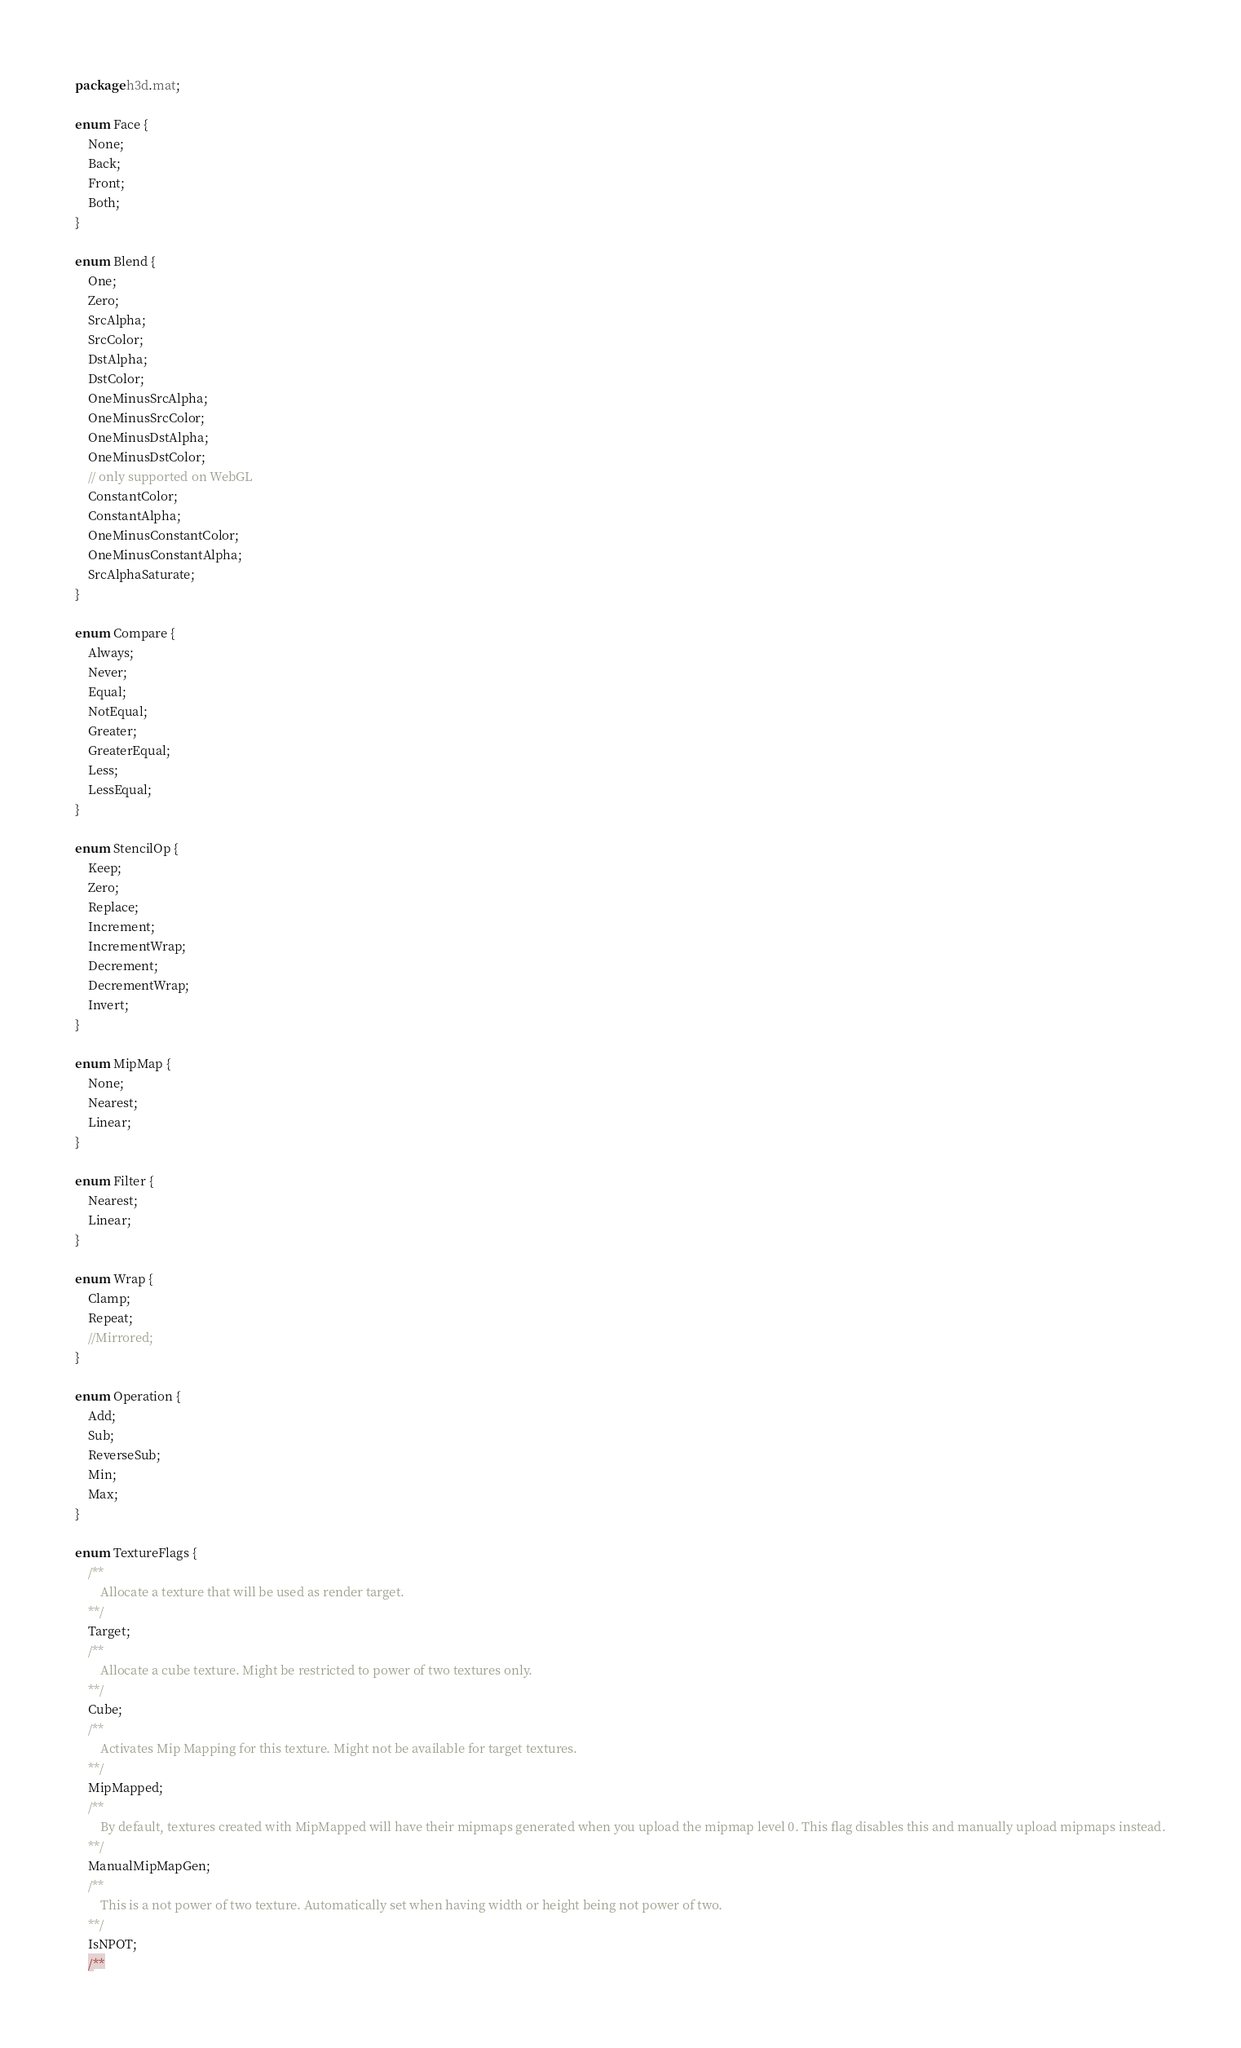<code> <loc_0><loc_0><loc_500><loc_500><_Haxe_>package h3d.mat;

enum Face {
	None;
	Back;
	Front;
	Both;
}

enum Blend {
	One;
	Zero;
	SrcAlpha;
	SrcColor;
	DstAlpha;
	DstColor;
	OneMinusSrcAlpha;
	OneMinusSrcColor;
	OneMinusDstAlpha;
	OneMinusDstColor;
	// only supported on WebGL
	ConstantColor;
	ConstantAlpha;
	OneMinusConstantColor;
	OneMinusConstantAlpha;
	SrcAlphaSaturate;
}

enum Compare {
	Always;
	Never;
	Equal;
	NotEqual;
	Greater;
	GreaterEqual;
	Less;
	LessEqual;
}

enum StencilOp {
	Keep;
	Zero;
	Replace;
	Increment;
	IncrementWrap;
	Decrement;
	DecrementWrap;
	Invert;
}

enum MipMap {
	None;
	Nearest;
	Linear;
}

enum Filter {
	Nearest;
	Linear;
}

enum Wrap {
	Clamp;
	Repeat;
	//Mirrored;
}

enum Operation {
	Add;
	Sub;
	ReverseSub;
	Min;
	Max;
}

enum TextureFlags {
	/**
		Allocate a texture that will be used as render target.
	**/
	Target;
	/**
		Allocate a cube texture. Might be restricted to power of two textures only.
	**/
	Cube;
	/**
		Activates Mip Mapping for this texture. Might not be available for target textures.
	**/
	MipMapped;
	/**
		By default, textures created with MipMapped will have their mipmaps generated when you upload the mipmap level 0. This flag disables this and manually upload mipmaps instead.
	**/
	ManualMipMapGen;
	/**
		This is a not power of two texture. Automatically set when having width or height being not power of two.
	**/
	IsNPOT;
	/**</code> 